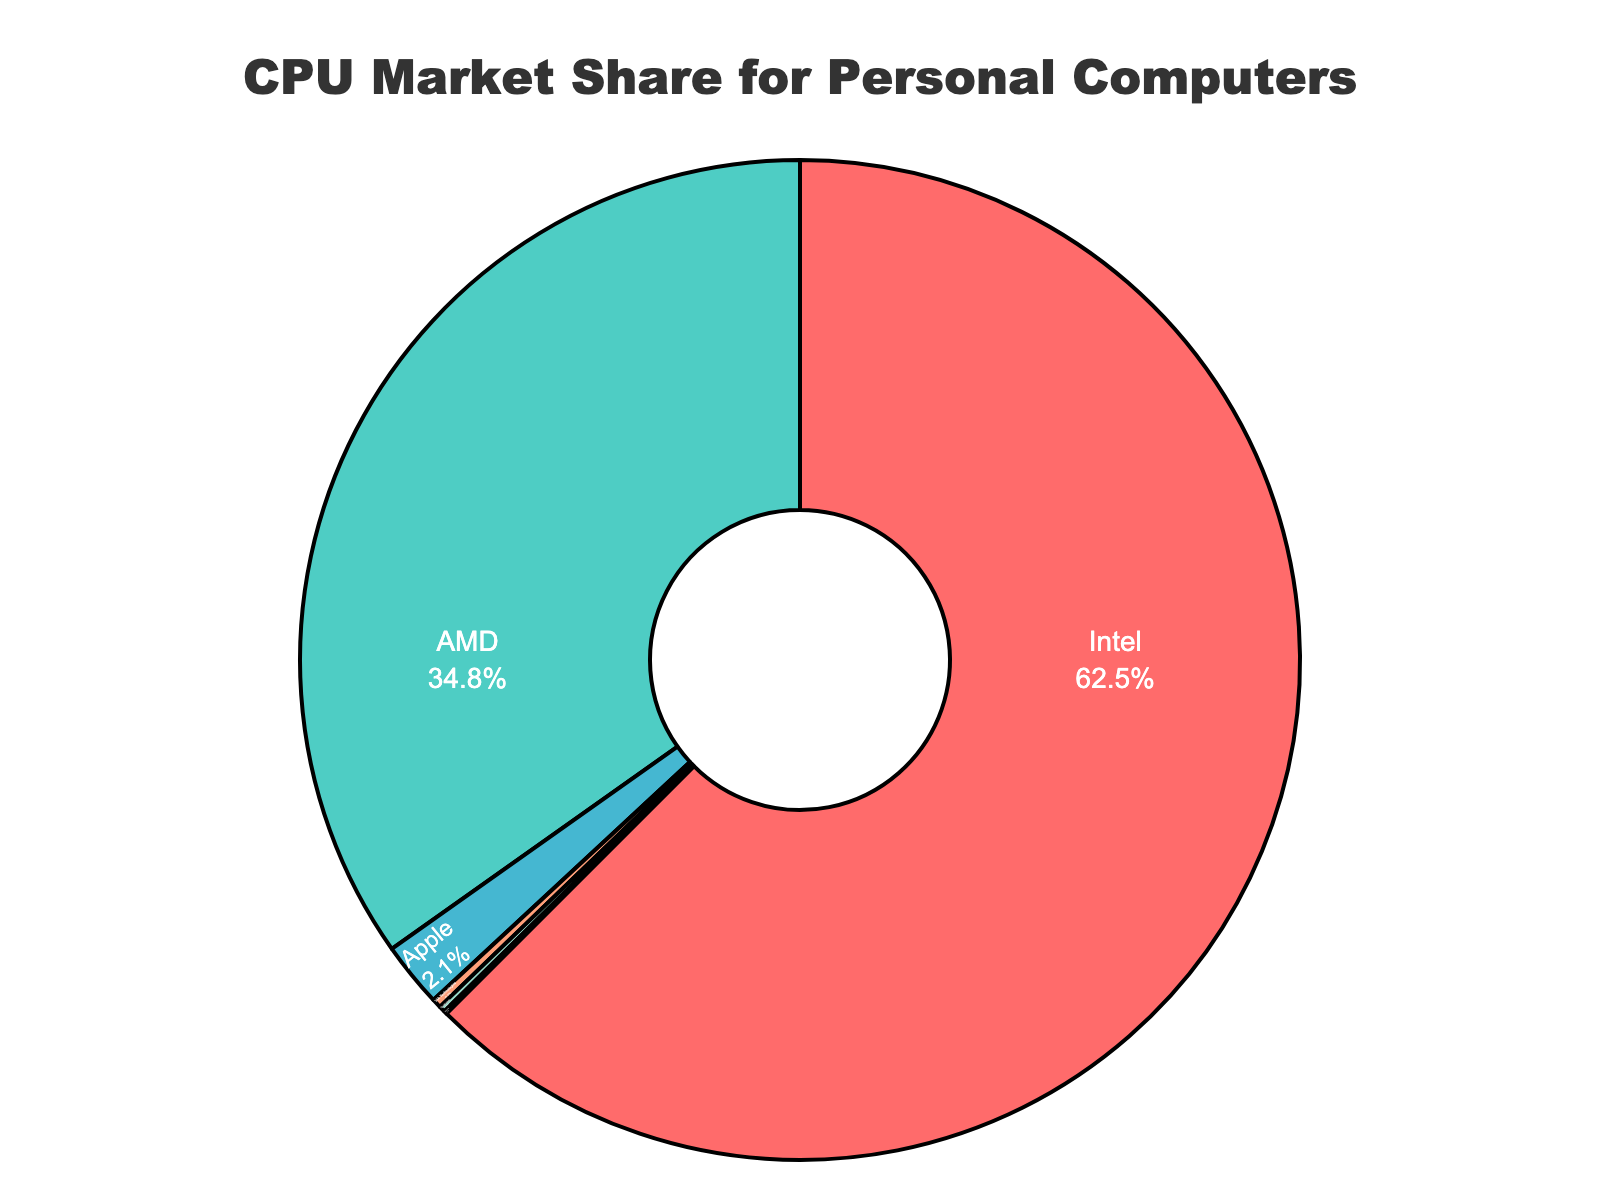What is Intel's market share percentage? The pie chart shows that the market share percentage for Intel is labeled within the section of the chart representing Intel.
Answer: 62.5% How much larger is Intel's market share compared to AMD's? Intel's market share is 62.5%, while AMD's market share is 34.8%. Subtract AMD's market share from Intel's: 62.5 - 34.8 = 27.7.
Answer: 27.7% What is the combined market share of Apple, VIA Technologies, Qualcomm, and Samsung? Add the market share percentages of Apple (2.1%), VIA Technologies (0.3%), Qualcomm (0.2%), and Samsung (0.1%): 2.1 + 0.3 + 0.2 + 0.1 = 2.7%.
Answer: 2.7% Which manufacturer has the smallest market share, and what is its percentage? The pie chart shows that Samsung has the smallest section representing its market share, and the percentage labeled within this section is 0.1%.
Answer: Samsung, 0.1% How do the market shares of Apple and VIA Technologies compare? Apple has a market share of 2.1%, and VIA Technologies has a market share of 0.3%. Apple’s market share is larger than VIA Technologies'.
Answer: Apple is larger What percentage of the market share is captured by manufacturers other than Intel and AMD? Add the market shares of Apple (2.1%), VIA Technologies (0.3%), Qualcomm (0.2%), and Samsung (0.1%): 2.1 + 0.3 + 0.2 + 0.1 = 2.7%.
Answer: 2.7% Is there any manufacturer with a market share more than 50%? The pie chart shows Intel's market share as 62.5%, which is more than 50%.
Answer: Yes What is the difference between the market share of AMD and Apple? Subtract Apple's market share from AMD's: 34.8 - 2.1 = 32.7.
Answer: 32.7 What percentage of the market share do manufacturers other than Intel represent together? Add the market shares of AMD (34.8%), Apple (2.1%), VIA Technologies (0.3%), Qualcomm (0.2%), and Samsung (0.1%): 34.8 + 2.1 + 0.3 + 0.2 + 0.1 = 37.5%.
Answer: 37.5% What share of the market do the two smallest manufacturers (Qualcomm and Samsung) hold together? Add the market shares of Qualcomm (0.2%) and Samsung (0.1%): 0.2 + 0.1 = 0.3%.
Answer: 0.3% 